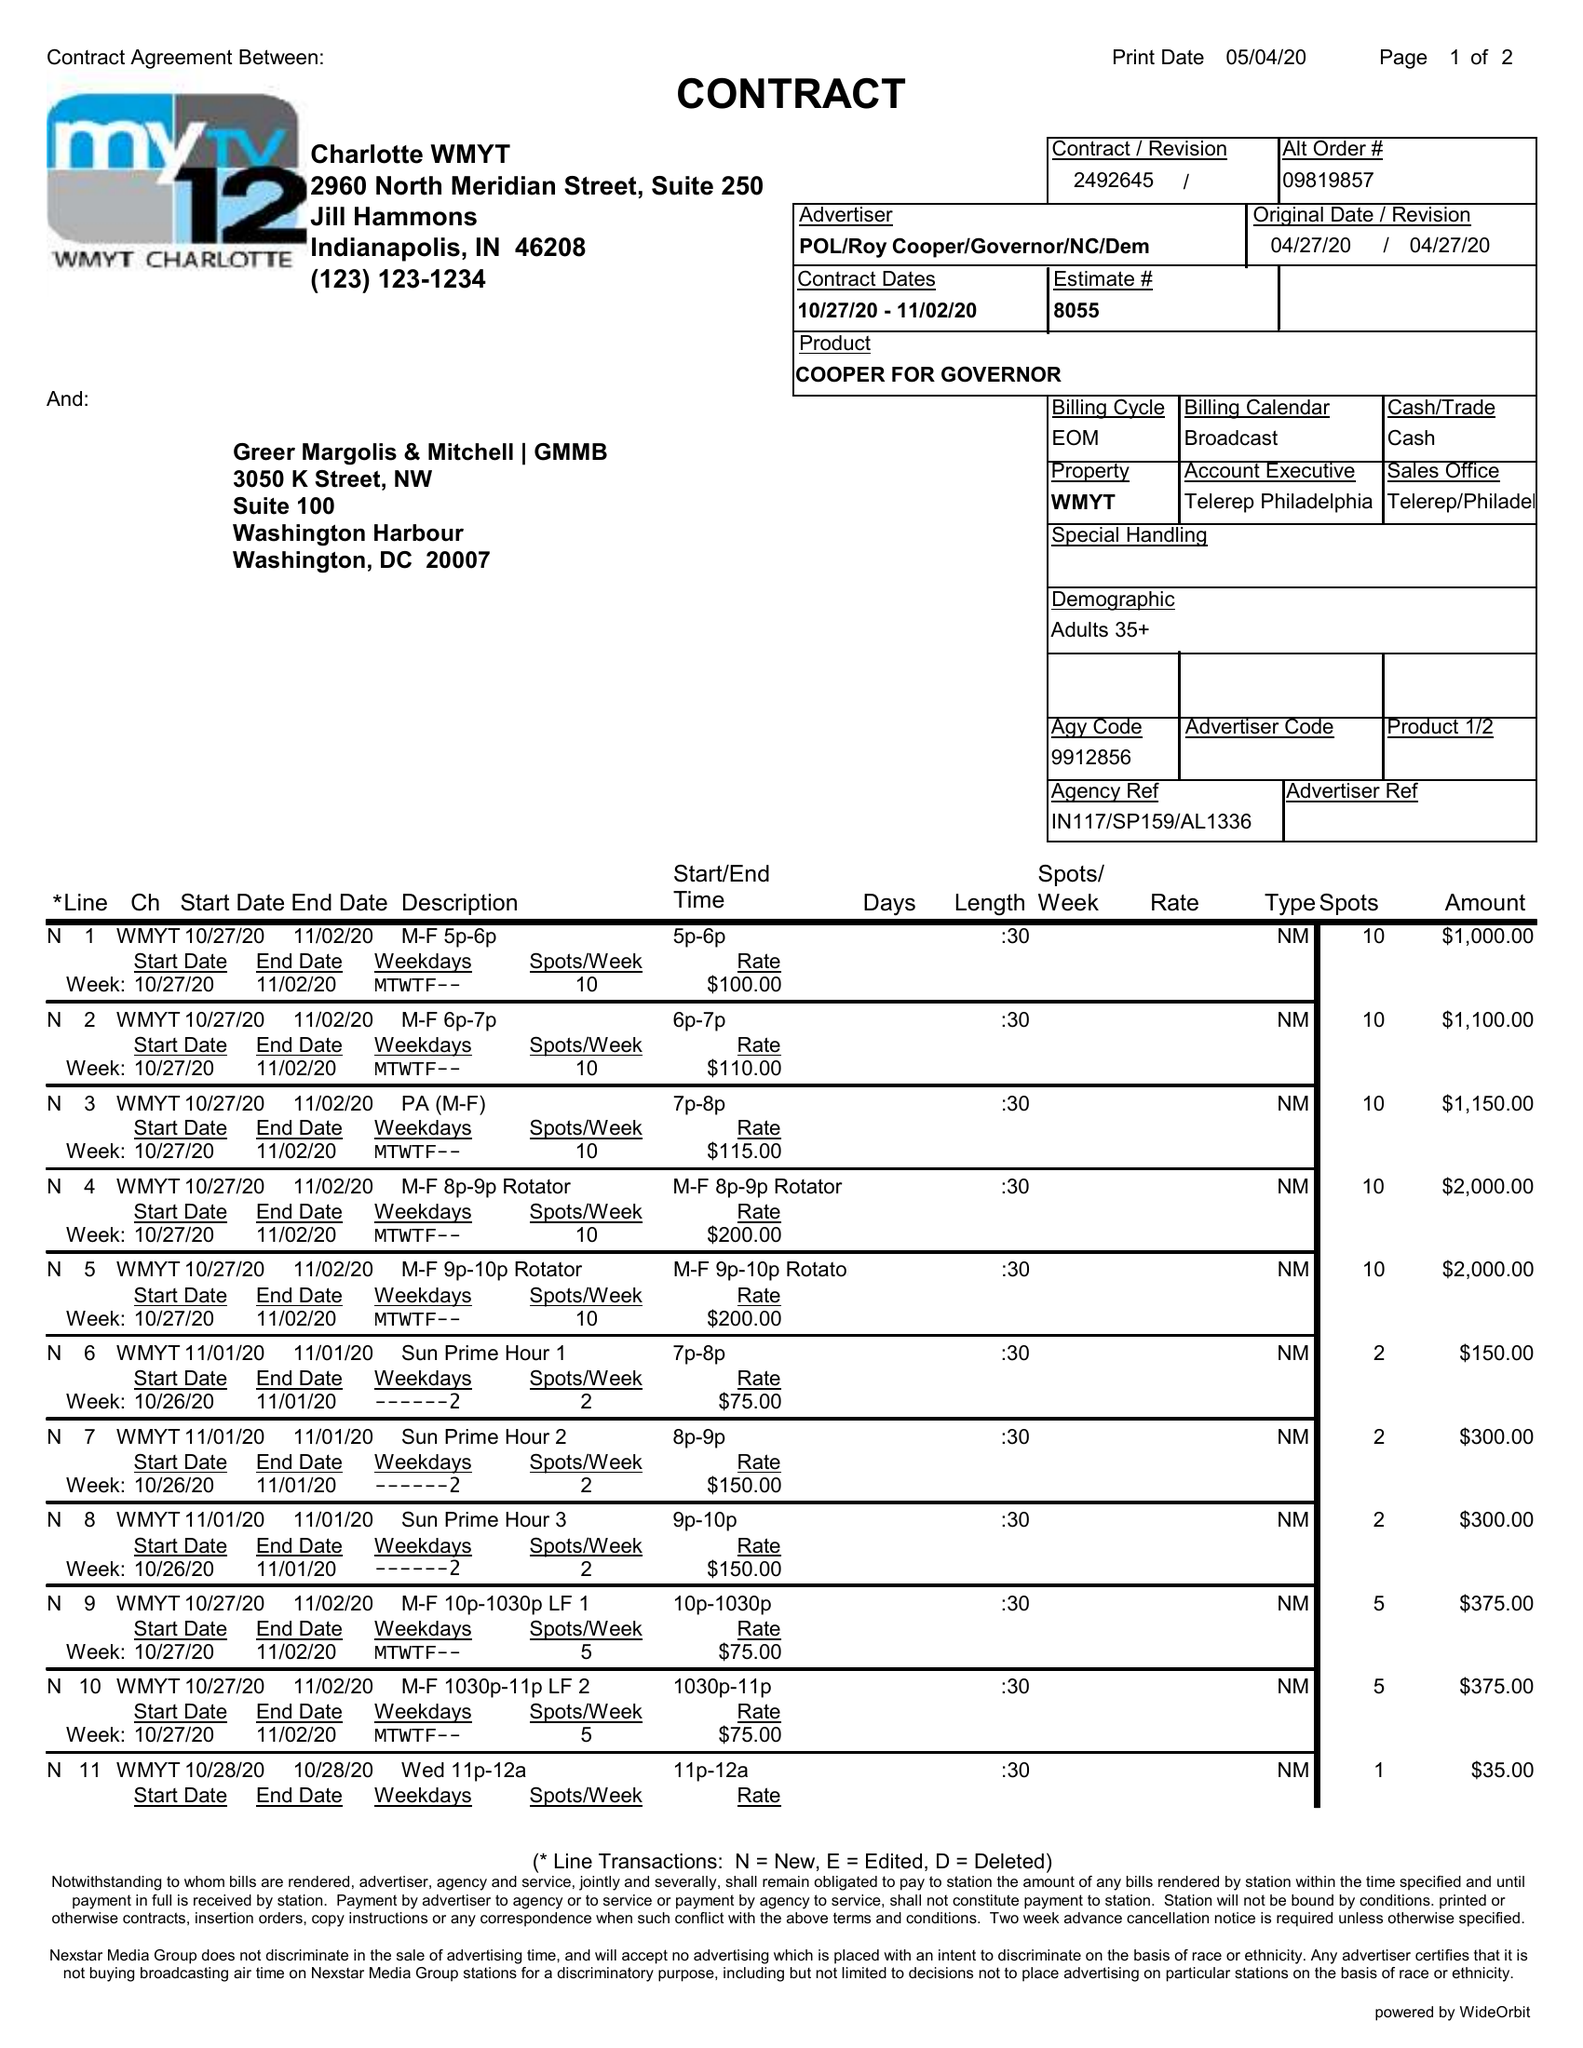What is the value for the advertiser?
Answer the question using a single word or phrase. POL/ROYCOOPER/GOVERNOR/NC/DEM 